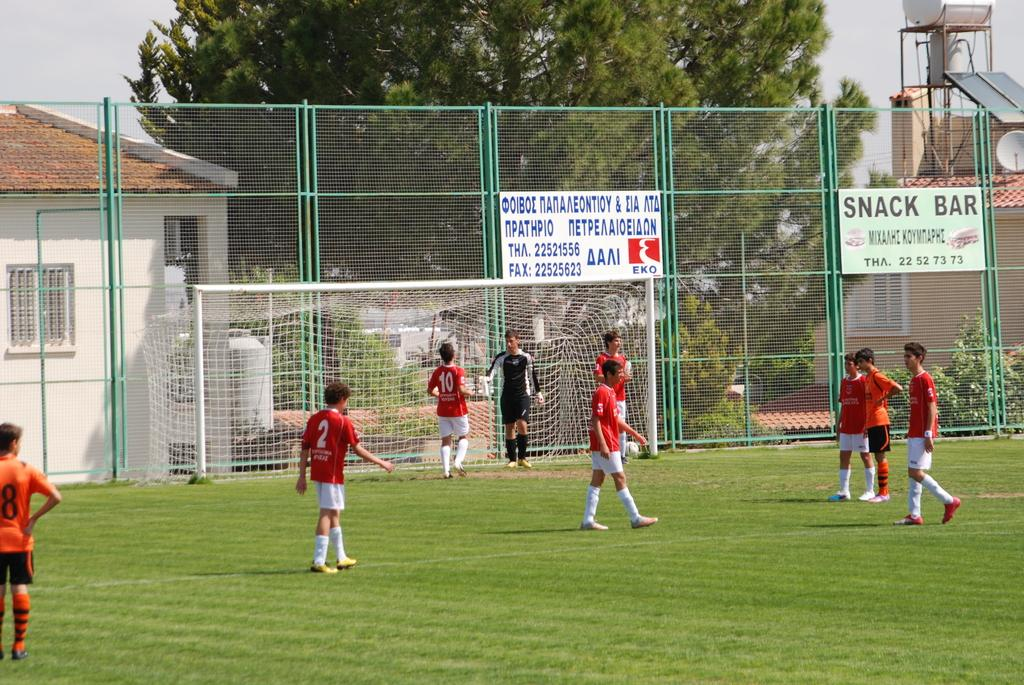<image>
Render a clear and concise summary of the photo. A group of soccer players mill around the field before a game in front of a fence with an ad for the Snack Bar on it. 